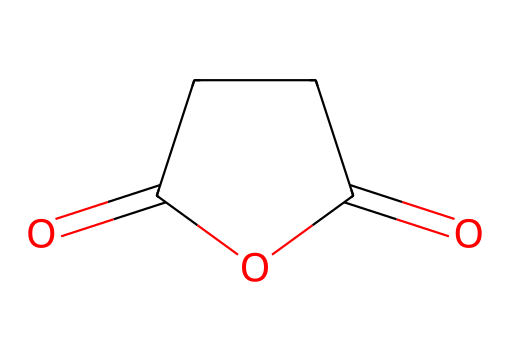What is the molecular formula of succinic anhydride? The structural formula reveals that the chemical contains four carbon atoms (C), significantly contributing to the total number of hydrogen atoms (H), and the presence of two oxygen atoms (O). This can be summarized as C4H4O3.
Answer: C4H4O3 How many rings are present in the structure? Examining the structure, it can be observed that there is one cyclic component formed by the carbon atoms and the two carbonyl groups, indicating a single ring.
Answer: 1 What is the functional group present in succinic anhydride? The structure contains carbonyl (C=O) groups and shows characteristics of anhydrides, confirming the presence of the anhydride functional group.
Answer: anhydride What type of reaction might succinic anhydride undergo in the presence of water? When incorporated in aqueous environments, succinic anhydride will typically undergo hydrolysis, which involves the reaction with water to form succinic acid, indicating its reactivity.
Answer: hydrolysis What is the significance of succinic anhydride in flame retardants? Succinic anhydride is used in various applications, and in flame retardants, it contributes to the polymer's ability to resist combustion by improving thermal stability, making it vital for enhancing safety standards in upholstery.
Answer: thermal stability How many double bonds are present in the structure? By analyzing the structural formula, there are two carbonyl (C=O) bonds present in the anhydride structure, representing two double bonds within the molecule.
Answer: 2 